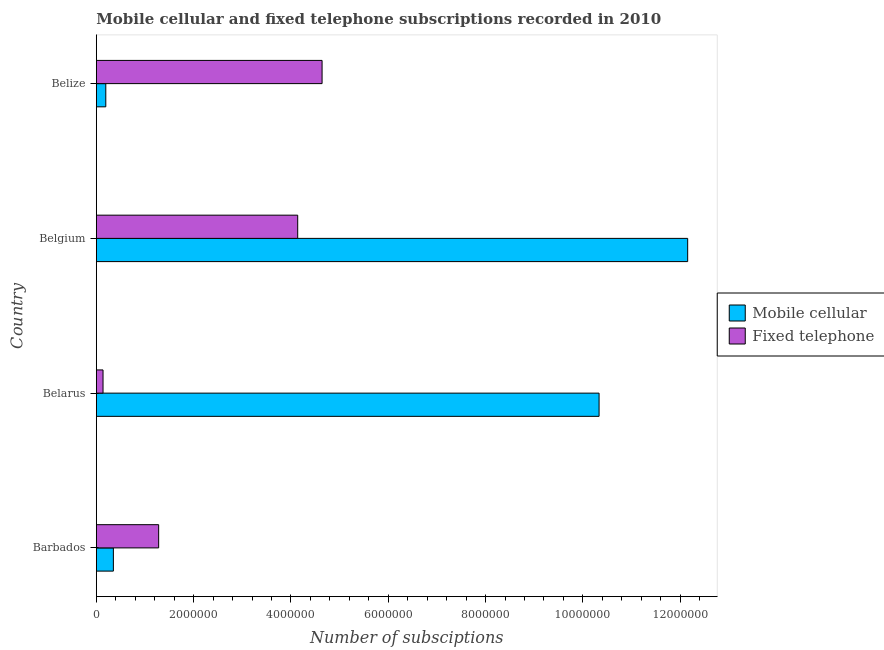How many different coloured bars are there?
Provide a short and direct response. 2. How many groups of bars are there?
Your answer should be very brief. 4. Are the number of bars per tick equal to the number of legend labels?
Offer a terse response. Yes. Are the number of bars on each tick of the Y-axis equal?
Provide a succinct answer. Yes. How many bars are there on the 2nd tick from the top?
Your response must be concise. 2. What is the label of the 4th group of bars from the top?
Provide a succinct answer. Barbados. What is the number of mobile cellular subscriptions in Belgium?
Offer a very short reply. 1.22e+07. Across all countries, what is the maximum number of mobile cellular subscriptions?
Ensure brevity in your answer.  1.22e+07. Across all countries, what is the minimum number of mobile cellular subscriptions?
Provide a short and direct response. 1.94e+05. In which country was the number of fixed telephone subscriptions maximum?
Offer a very short reply. Belize. In which country was the number of fixed telephone subscriptions minimum?
Your response must be concise. Belarus. What is the total number of mobile cellular subscriptions in the graph?
Your answer should be very brief. 2.30e+07. What is the difference between the number of fixed telephone subscriptions in Barbados and that in Belgium?
Provide a short and direct response. -2.86e+06. What is the difference between the number of fixed telephone subscriptions in Belarus and the number of mobile cellular subscriptions in Belize?
Keep it short and to the point. -5.67e+04. What is the average number of mobile cellular subscriptions per country?
Provide a short and direct response. 5.76e+06. What is the difference between the number of fixed telephone subscriptions and number of mobile cellular subscriptions in Barbados?
Give a very brief answer. 9.31e+05. In how many countries, is the number of fixed telephone subscriptions greater than 3200000 ?
Make the answer very short. 2. What is the ratio of the number of mobile cellular subscriptions in Barbados to that in Belize?
Ensure brevity in your answer.  1.8. Is the number of fixed telephone subscriptions in Belarus less than that in Belgium?
Your response must be concise. Yes. Is the difference between the number of mobile cellular subscriptions in Belgium and Belize greater than the difference between the number of fixed telephone subscriptions in Belgium and Belize?
Offer a very short reply. Yes. What is the difference between the highest and the second highest number of fixed telephone subscriptions?
Keep it short and to the point. 5.01e+05. What is the difference between the highest and the lowest number of fixed telephone subscriptions?
Make the answer very short. 4.50e+06. Is the sum of the number of mobile cellular subscriptions in Belgium and Belize greater than the maximum number of fixed telephone subscriptions across all countries?
Your answer should be very brief. Yes. What does the 1st bar from the top in Belize represents?
Ensure brevity in your answer.  Fixed telephone. What does the 2nd bar from the bottom in Belize represents?
Make the answer very short. Fixed telephone. How many countries are there in the graph?
Your answer should be compact. 4. What is the difference between two consecutive major ticks on the X-axis?
Make the answer very short. 2.00e+06. Are the values on the major ticks of X-axis written in scientific E-notation?
Offer a terse response. No. Does the graph contain grids?
Make the answer very short. No. How many legend labels are there?
Provide a short and direct response. 2. What is the title of the graph?
Keep it short and to the point. Mobile cellular and fixed telephone subscriptions recorded in 2010. Does "Secondary" appear as one of the legend labels in the graph?
Offer a very short reply. No. What is the label or title of the X-axis?
Make the answer very short. Number of subsciptions. What is the label or title of the Y-axis?
Keep it short and to the point. Country. What is the Number of subsciptions in Mobile cellular in Barbados?
Your answer should be very brief. 3.50e+05. What is the Number of subsciptions in Fixed telephone in Barbados?
Offer a very short reply. 1.28e+06. What is the Number of subsciptions in Mobile cellular in Belarus?
Offer a very short reply. 1.03e+07. What is the Number of subsciptions of Fixed telephone in Belarus?
Provide a succinct answer. 1.37e+05. What is the Number of subsciptions of Mobile cellular in Belgium?
Provide a succinct answer. 1.22e+07. What is the Number of subsciptions of Fixed telephone in Belgium?
Your answer should be very brief. 4.14e+06. What is the Number of subsciptions in Mobile cellular in Belize?
Offer a very short reply. 1.94e+05. What is the Number of subsciptions in Fixed telephone in Belize?
Make the answer very short. 4.64e+06. Across all countries, what is the maximum Number of subsciptions of Mobile cellular?
Offer a terse response. 1.22e+07. Across all countries, what is the maximum Number of subsciptions in Fixed telephone?
Offer a very short reply. 4.64e+06. Across all countries, what is the minimum Number of subsciptions of Mobile cellular?
Your answer should be compact. 1.94e+05. Across all countries, what is the minimum Number of subsciptions of Fixed telephone?
Provide a succinct answer. 1.37e+05. What is the total Number of subsciptions of Mobile cellular in the graph?
Your response must be concise. 2.30e+07. What is the total Number of subsciptions of Fixed telephone in the graph?
Give a very brief answer. 1.02e+07. What is the difference between the Number of subsciptions in Mobile cellular in Barbados and that in Belarus?
Your response must be concise. -9.98e+06. What is the difference between the Number of subsciptions of Fixed telephone in Barbados and that in Belarus?
Your answer should be very brief. 1.14e+06. What is the difference between the Number of subsciptions of Mobile cellular in Barbados and that in Belgium?
Ensure brevity in your answer.  -1.18e+07. What is the difference between the Number of subsciptions in Fixed telephone in Barbados and that in Belgium?
Provide a succinct answer. -2.86e+06. What is the difference between the Number of subsciptions in Mobile cellular in Barbados and that in Belize?
Give a very brief answer. 1.56e+05. What is the difference between the Number of subsciptions of Fixed telephone in Barbados and that in Belize?
Your answer should be compact. -3.36e+06. What is the difference between the Number of subsciptions in Mobile cellular in Belarus and that in Belgium?
Give a very brief answer. -1.82e+06. What is the difference between the Number of subsciptions in Fixed telephone in Belarus and that in Belgium?
Your answer should be compact. -4.00e+06. What is the difference between the Number of subsciptions of Mobile cellular in Belarus and that in Belize?
Provide a succinct answer. 1.01e+07. What is the difference between the Number of subsciptions in Fixed telephone in Belarus and that in Belize?
Make the answer very short. -4.50e+06. What is the difference between the Number of subsciptions in Mobile cellular in Belgium and that in Belize?
Your answer should be compact. 1.20e+07. What is the difference between the Number of subsciptions in Fixed telephone in Belgium and that in Belize?
Make the answer very short. -5.01e+05. What is the difference between the Number of subsciptions of Mobile cellular in Barbados and the Number of subsciptions of Fixed telephone in Belarus?
Provide a short and direct response. 2.13e+05. What is the difference between the Number of subsciptions of Mobile cellular in Barbados and the Number of subsciptions of Fixed telephone in Belgium?
Offer a terse response. -3.79e+06. What is the difference between the Number of subsciptions of Mobile cellular in Barbados and the Number of subsciptions of Fixed telephone in Belize?
Provide a short and direct response. -4.29e+06. What is the difference between the Number of subsciptions in Mobile cellular in Belarus and the Number of subsciptions in Fixed telephone in Belgium?
Offer a terse response. 6.19e+06. What is the difference between the Number of subsciptions of Mobile cellular in Belarus and the Number of subsciptions of Fixed telephone in Belize?
Provide a succinct answer. 5.69e+06. What is the difference between the Number of subsciptions in Mobile cellular in Belgium and the Number of subsciptions in Fixed telephone in Belize?
Provide a succinct answer. 7.51e+06. What is the average Number of subsciptions of Mobile cellular per country?
Make the answer very short. 5.76e+06. What is the average Number of subsciptions of Fixed telephone per country?
Make the answer very short. 2.55e+06. What is the difference between the Number of subsciptions of Mobile cellular and Number of subsciptions of Fixed telephone in Barbados?
Offer a very short reply. -9.31e+05. What is the difference between the Number of subsciptions in Mobile cellular and Number of subsciptions in Fixed telephone in Belarus?
Make the answer very short. 1.02e+07. What is the difference between the Number of subsciptions in Mobile cellular and Number of subsciptions in Fixed telephone in Belgium?
Keep it short and to the point. 8.02e+06. What is the difference between the Number of subsciptions in Mobile cellular and Number of subsciptions in Fixed telephone in Belize?
Ensure brevity in your answer.  -4.45e+06. What is the ratio of the Number of subsciptions in Mobile cellular in Barbados to that in Belarus?
Offer a terse response. 0.03. What is the ratio of the Number of subsciptions in Fixed telephone in Barbados to that in Belarus?
Keep it short and to the point. 9.32. What is the ratio of the Number of subsciptions of Mobile cellular in Barbados to that in Belgium?
Offer a terse response. 0.03. What is the ratio of the Number of subsciptions of Fixed telephone in Barbados to that in Belgium?
Give a very brief answer. 0.31. What is the ratio of the Number of subsciptions of Mobile cellular in Barbados to that in Belize?
Your answer should be compact. 1.8. What is the ratio of the Number of subsciptions of Fixed telephone in Barbados to that in Belize?
Ensure brevity in your answer.  0.28. What is the ratio of the Number of subsciptions of Mobile cellular in Belarus to that in Belgium?
Your answer should be compact. 0.85. What is the ratio of the Number of subsciptions in Fixed telephone in Belarus to that in Belgium?
Give a very brief answer. 0.03. What is the ratio of the Number of subsciptions of Mobile cellular in Belarus to that in Belize?
Offer a very short reply. 53.21. What is the ratio of the Number of subsciptions in Fixed telephone in Belarus to that in Belize?
Make the answer very short. 0.03. What is the ratio of the Number of subsciptions in Mobile cellular in Belgium to that in Belize?
Offer a terse response. 62.58. What is the ratio of the Number of subsciptions in Fixed telephone in Belgium to that in Belize?
Offer a very short reply. 0.89. What is the difference between the highest and the second highest Number of subsciptions in Mobile cellular?
Your answer should be compact. 1.82e+06. What is the difference between the highest and the second highest Number of subsciptions in Fixed telephone?
Your answer should be very brief. 5.01e+05. What is the difference between the highest and the lowest Number of subsciptions in Mobile cellular?
Offer a very short reply. 1.20e+07. What is the difference between the highest and the lowest Number of subsciptions in Fixed telephone?
Provide a succinct answer. 4.50e+06. 